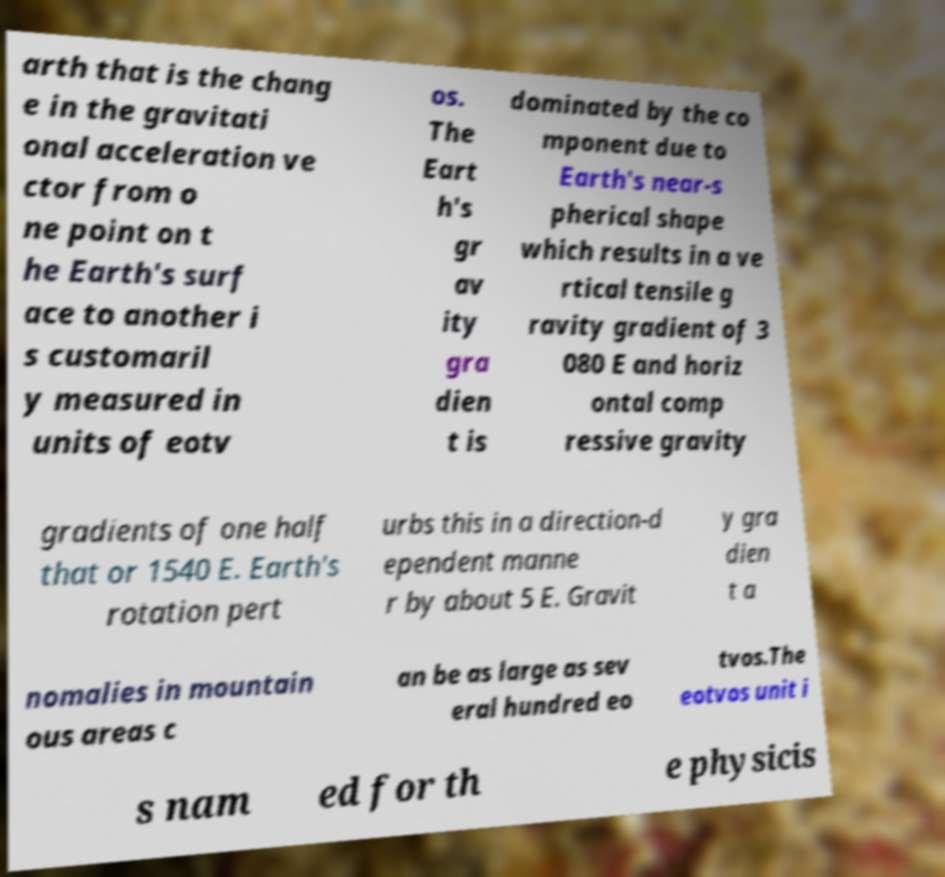Can you read and provide the text displayed in the image?This photo seems to have some interesting text. Can you extract and type it out for me? arth that is the chang e in the gravitati onal acceleration ve ctor from o ne point on t he Earth's surf ace to another i s customaril y measured in units of eotv os. The Eart h's gr av ity gra dien t is dominated by the co mponent due to Earth's near-s pherical shape which results in a ve rtical tensile g ravity gradient of 3 080 E and horiz ontal comp ressive gravity gradients of one half that or 1540 E. Earth's rotation pert urbs this in a direction-d ependent manne r by about 5 E. Gravit y gra dien t a nomalies in mountain ous areas c an be as large as sev eral hundred eo tvos.The eotvos unit i s nam ed for th e physicis 